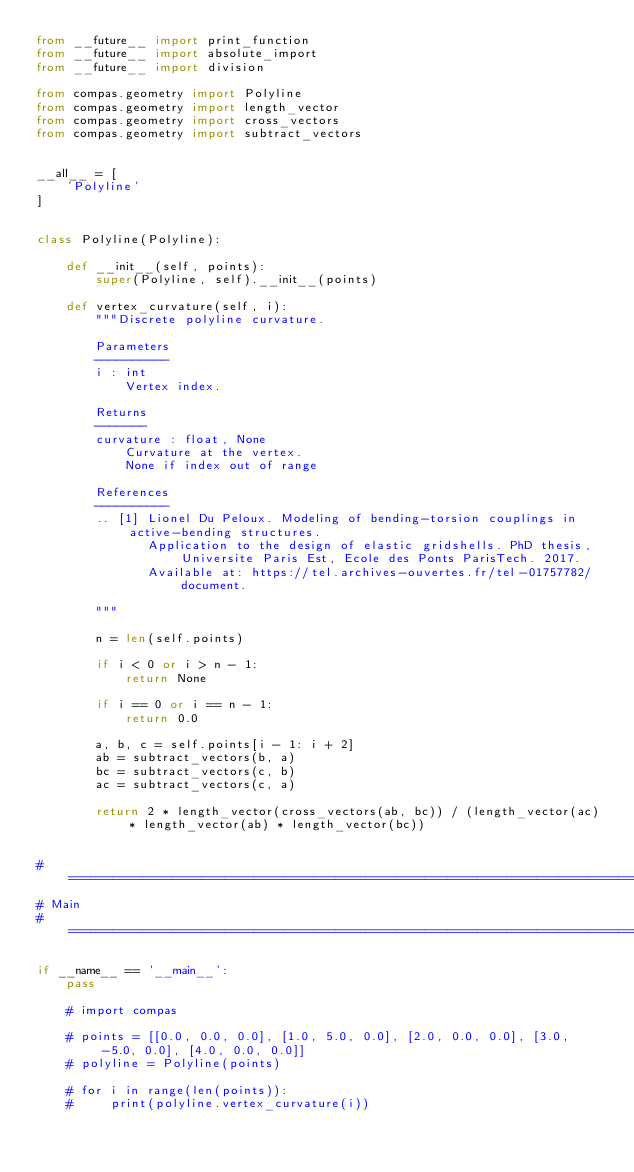<code> <loc_0><loc_0><loc_500><loc_500><_Python_>from __future__ import print_function
from __future__ import absolute_import
from __future__ import division

from compas.geometry import Polyline
from compas.geometry import length_vector
from compas.geometry import cross_vectors
from compas.geometry import subtract_vectors


__all__ = [
    'Polyline'
]


class Polyline(Polyline):

    def __init__(self, points):
        super(Polyline, self).__init__(points)

    def vertex_curvature(self, i):
        """Discrete polyline curvature.

        Parameters
        ----------
        i : int
            Vertex index.

        Returns
        -------
        curvature : float, None
            Curvature at the vertex.
            None if index out of range

        References
        ----------
        .. [1] Lionel Du Peloux. Modeling of bending-torsion couplings in active-bending structures.
               Application to the design of elastic gridshells. PhD thesis, Universite Paris Est, Ecole des Ponts ParisTech. 2017.
               Available at: https://tel.archives-ouvertes.fr/tel-01757782/document.

        """

        n = len(self.points)

        if i < 0 or i > n - 1:
            return None

        if i == 0 or i == n - 1:
            return 0.0

        a, b, c = self.points[i - 1: i + 2]
        ab = subtract_vectors(b, a)
        bc = subtract_vectors(c, b)
        ac = subtract_vectors(c, a)

        return 2 * length_vector(cross_vectors(ab, bc)) / (length_vector(ac) * length_vector(ab) * length_vector(bc))


# ==============================================================================
# Main
# ==============================================================================

if __name__ == '__main__':
    pass

    # import compas

    # points = [[0.0, 0.0, 0.0], [1.0, 5.0, 0.0], [2.0, 0.0, 0.0], [3.0, -5.0, 0.0], [4.0, 0.0, 0.0]]
    # polyline = Polyline(points)

    # for i in range(len(points)):
    #     print(polyline.vertex_curvature(i))
</code> 